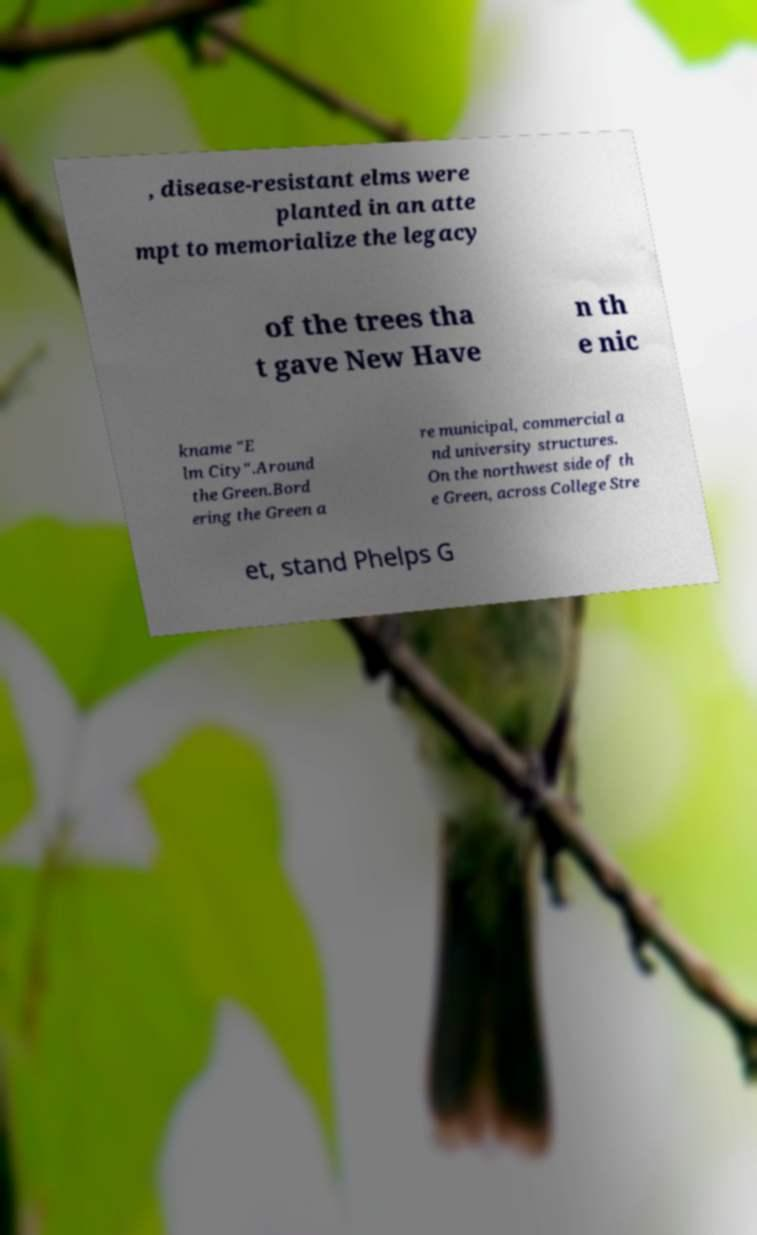What messages or text are displayed in this image? I need them in a readable, typed format. , disease-resistant elms were planted in an atte mpt to memorialize the legacy of the trees tha t gave New Have n th e nic kname "E lm City".Around the Green.Bord ering the Green a re municipal, commercial a nd university structures. On the northwest side of th e Green, across College Stre et, stand Phelps G 